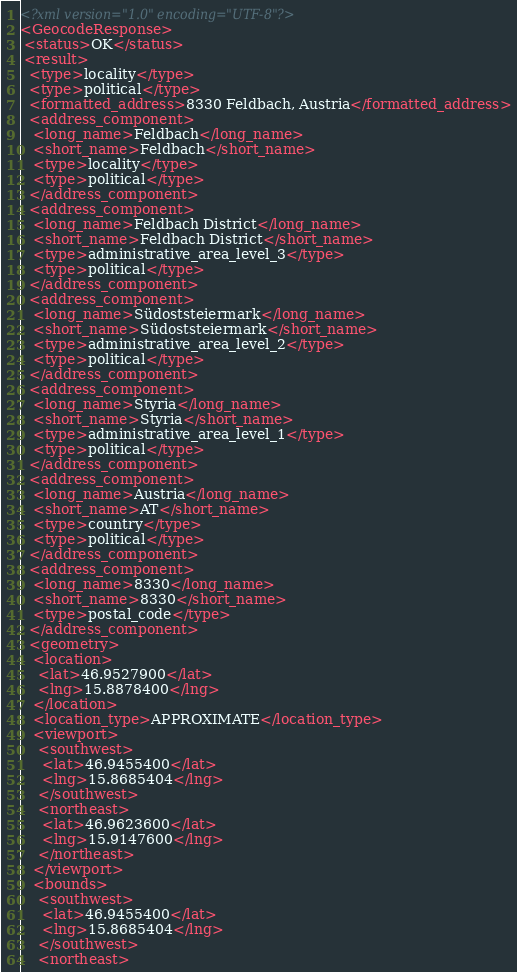<code> <loc_0><loc_0><loc_500><loc_500><_XML_><?xml version="1.0" encoding="UTF-8"?>
<GeocodeResponse>
 <status>OK</status>
 <result>
  <type>locality</type>
  <type>political</type>
  <formatted_address>8330 Feldbach, Austria</formatted_address>
  <address_component>
   <long_name>Feldbach</long_name>
   <short_name>Feldbach</short_name>
   <type>locality</type>
   <type>political</type>
  </address_component>
  <address_component>
   <long_name>Feldbach District</long_name>
   <short_name>Feldbach District</short_name>
   <type>administrative_area_level_3</type>
   <type>political</type>
  </address_component>
  <address_component>
   <long_name>Südoststeiermark</long_name>
   <short_name>Südoststeiermark</short_name>
   <type>administrative_area_level_2</type>
   <type>political</type>
  </address_component>
  <address_component>
   <long_name>Styria</long_name>
   <short_name>Styria</short_name>
   <type>administrative_area_level_1</type>
   <type>political</type>
  </address_component>
  <address_component>
   <long_name>Austria</long_name>
   <short_name>AT</short_name>
   <type>country</type>
   <type>political</type>
  </address_component>
  <address_component>
   <long_name>8330</long_name>
   <short_name>8330</short_name>
   <type>postal_code</type>
  </address_component>
  <geometry>
   <location>
    <lat>46.9527900</lat>
    <lng>15.8878400</lng>
   </location>
   <location_type>APPROXIMATE</location_type>
   <viewport>
    <southwest>
     <lat>46.9455400</lat>
     <lng>15.8685404</lng>
    </southwest>
    <northeast>
     <lat>46.9623600</lat>
     <lng>15.9147600</lng>
    </northeast>
   </viewport>
   <bounds>
    <southwest>
     <lat>46.9455400</lat>
     <lng>15.8685404</lng>
    </southwest>
    <northeast></code> 